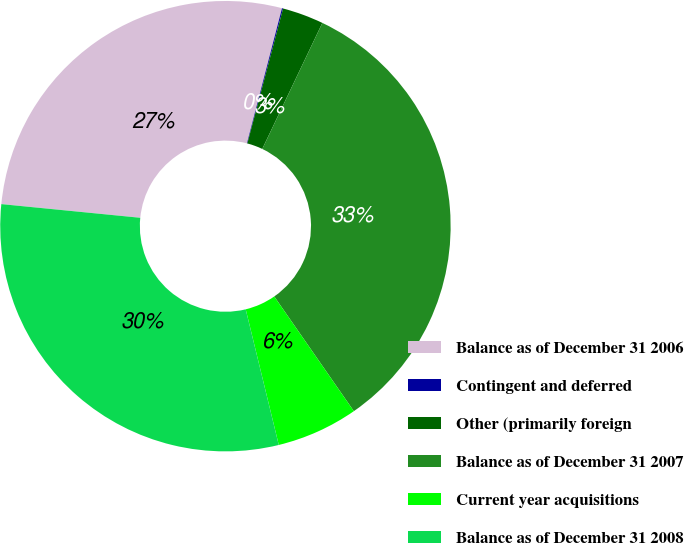Convert chart. <chart><loc_0><loc_0><loc_500><loc_500><pie_chart><fcel>Balance as of December 31 2006<fcel>Contingent and deferred<fcel>Other (primarily foreign<fcel>Balance as of December 31 2007<fcel>Current year acquisitions<fcel>Balance as of December 31 2008<nl><fcel>27.48%<fcel>0.08%<fcel>2.96%<fcel>33.26%<fcel>5.85%<fcel>30.37%<nl></chart> 